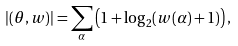<formula> <loc_0><loc_0><loc_500><loc_500>| ( \theta , w ) | = \sum _ { \alpha } \left ( 1 + \log _ { 2 } ( w ( \alpha ) + 1 ) \right ) ,</formula> 